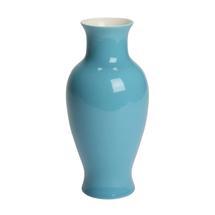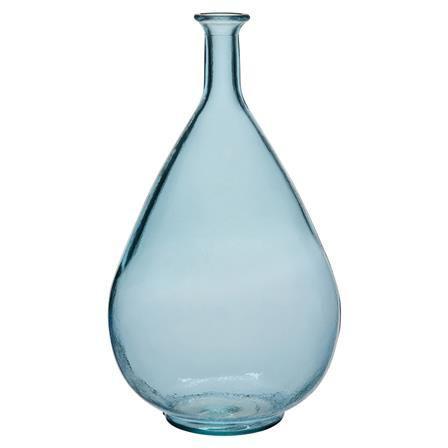The first image is the image on the left, the second image is the image on the right. Given the left and right images, does the statement "The vases are made of repurposed bottles." hold true? Answer yes or no. No. The first image is the image on the left, the second image is the image on the right. For the images shown, is this caption "There are at least 5 glass jars." true? Answer yes or no. No. 